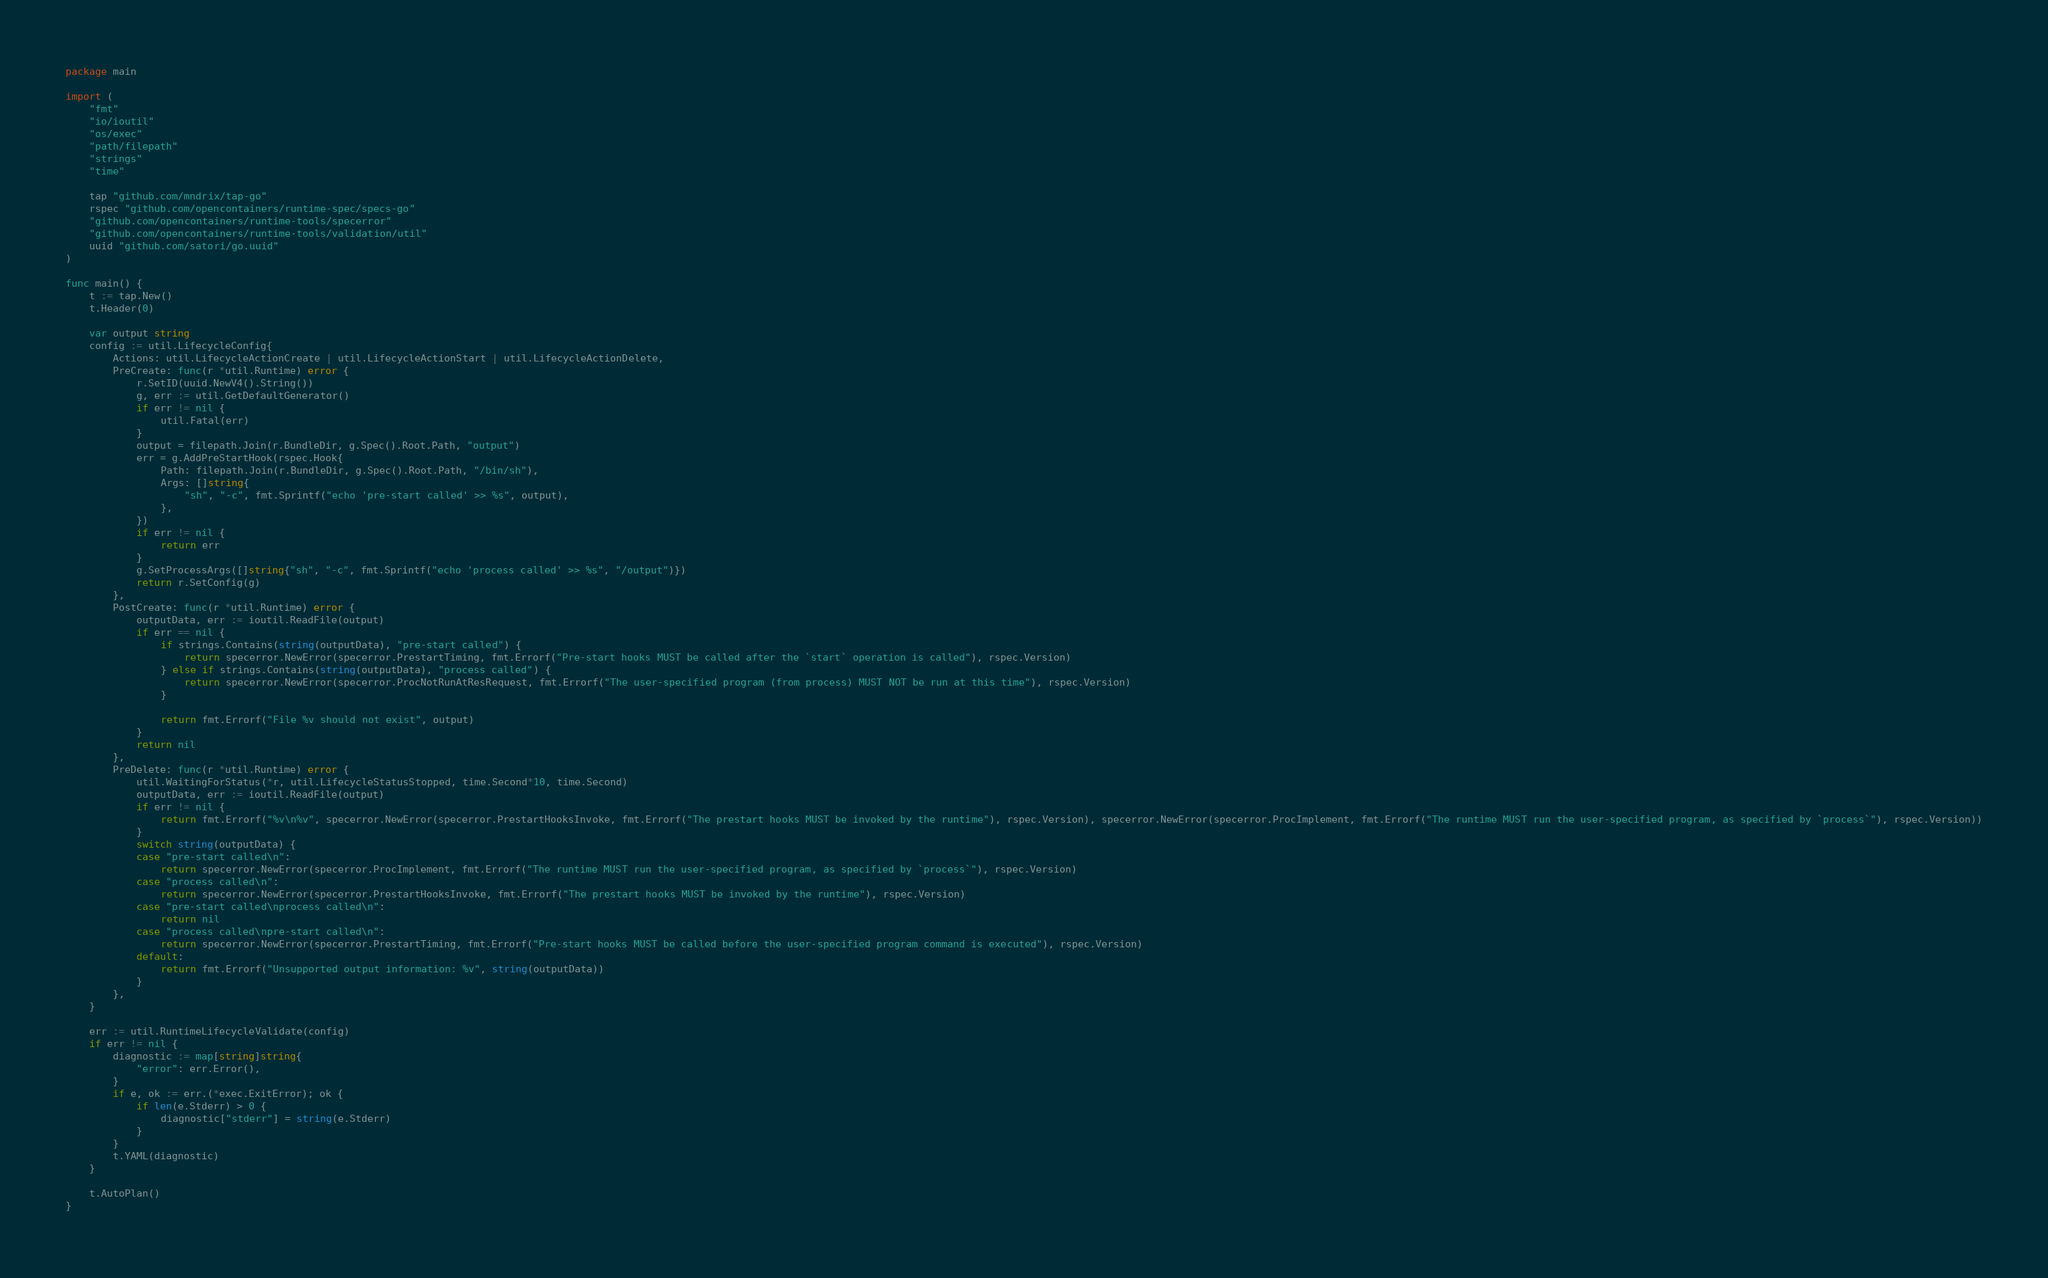<code> <loc_0><loc_0><loc_500><loc_500><_Go_>package main

import (
	"fmt"
	"io/ioutil"
	"os/exec"
	"path/filepath"
	"strings"
	"time"

	tap "github.com/mndrix/tap-go"
	rspec "github.com/opencontainers/runtime-spec/specs-go"
	"github.com/opencontainers/runtime-tools/specerror"
	"github.com/opencontainers/runtime-tools/validation/util"
	uuid "github.com/satori/go.uuid"
)

func main() {
	t := tap.New()
	t.Header(0)

	var output string
	config := util.LifecycleConfig{
		Actions: util.LifecycleActionCreate | util.LifecycleActionStart | util.LifecycleActionDelete,
		PreCreate: func(r *util.Runtime) error {
			r.SetID(uuid.NewV4().String())
			g, err := util.GetDefaultGenerator()
			if err != nil {
				util.Fatal(err)
			}
			output = filepath.Join(r.BundleDir, g.Spec().Root.Path, "output")
			err = g.AddPreStartHook(rspec.Hook{
				Path: filepath.Join(r.BundleDir, g.Spec().Root.Path, "/bin/sh"),
				Args: []string{
					"sh", "-c", fmt.Sprintf("echo 'pre-start called' >> %s", output),
				},
			})
			if err != nil {
				return err
			}
			g.SetProcessArgs([]string{"sh", "-c", fmt.Sprintf("echo 'process called' >> %s", "/output")})
			return r.SetConfig(g)
		},
		PostCreate: func(r *util.Runtime) error {
			outputData, err := ioutil.ReadFile(output)
			if err == nil {
				if strings.Contains(string(outputData), "pre-start called") {
					return specerror.NewError(specerror.PrestartTiming, fmt.Errorf("Pre-start hooks MUST be called after the `start` operation is called"), rspec.Version)
				} else if strings.Contains(string(outputData), "process called") {
					return specerror.NewError(specerror.ProcNotRunAtResRequest, fmt.Errorf("The user-specified program (from process) MUST NOT be run at this time"), rspec.Version)
				}

				return fmt.Errorf("File %v should not exist", output)
			}
			return nil
		},
		PreDelete: func(r *util.Runtime) error {
			util.WaitingForStatus(*r, util.LifecycleStatusStopped, time.Second*10, time.Second)
			outputData, err := ioutil.ReadFile(output)
			if err != nil {
				return fmt.Errorf("%v\n%v", specerror.NewError(specerror.PrestartHooksInvoke, fmt.Errorf("The prestart hooks MUST be invoked by the runtime"), rspec.Version), specerror.NewError(specerror.ProcImplement, fmt.Errorf("The runtime MUST run the user-specified program, as specified by `process`"), rspec.Version))
			}
			switch string(outputData) {
			case "pre-start called\n":
				return specerror.NewError(specerror.ProcImplement, fmt.Errorf("The runtime MUST run the user-specified program, as specified by `process`"), rspec.Version)
			case "process called\n":
				return specerror.NewError(specerror.PrestartHooksInvoke, fmt.Errorf("The prestart hooks MUST be invoked by the runtime"), rspec.Version)
			case "pre-start called\nprocess called\n":
				return nil
			case "process called\npre-start called\n":
				return specerror.NewError(specerror.PrestartTiming, fmt.Errorf("Pre-start hooks MUST be called before the user-specified program command is executed"), rspec.Version)
			default:
				return fmt.Errorf("Unsupported output information: %v", string(outputData))
			}
		},
	}

	err := util.RuntimeLifecycleValidate(config)
	if err != nil {
		diagnostic := map[string]string{
			"error": err.Error(),
		}
		if e, ok := err.(*exec.ExitError); ok {
			if len(e.Stderr) > 0 {
				diagnostic["stderr"] = string(e.Stderr)
			}
		}
		t.YAML(diagnostic)
	}

	t.AutoPlan()
}
</code> 